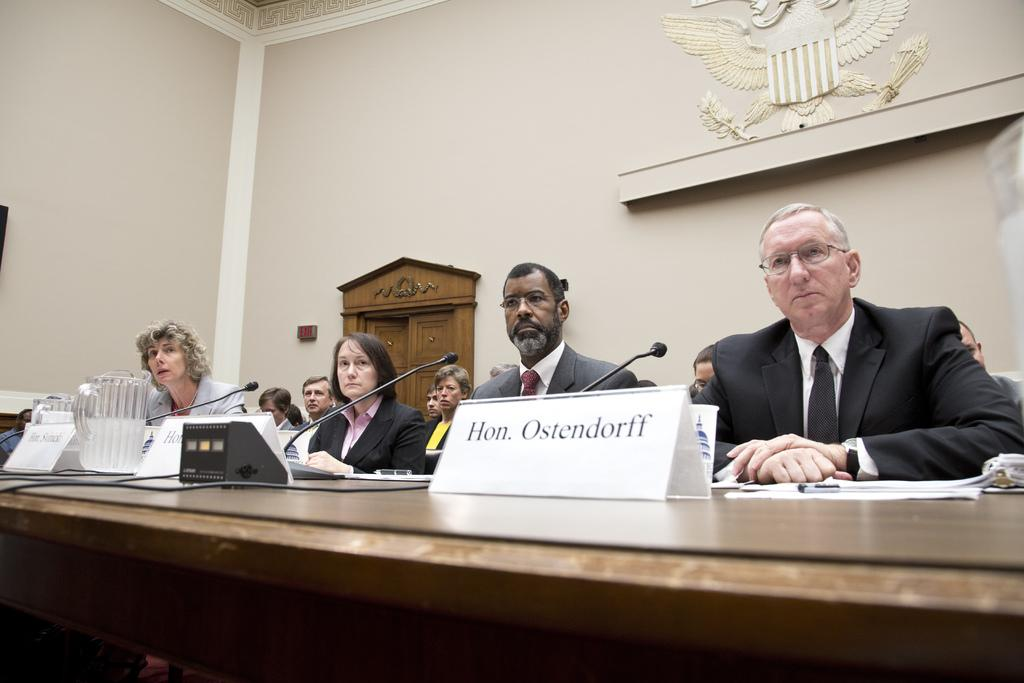What are the people in the image doing? The persons sitting in the image are likely engaged in a meeting or discussion. What is the main object in the image? The table is the main object in the image. What items can be seen on the table? Name boards, glasses, and microphones are present on the table. What can be seen in the background of the image? There is a wall in the background of the image. How much salt is on the table in the image? There is no salt visible on the table in the image. What type of structure is depicted in the image? The image does not depict a specific structure; it shows a group of people sitting around a table with various items. 